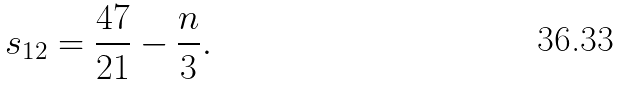Convert formula to latex. <formula><loc_0><loc_0><loc_500><loc_500>s _ { 1 2 } = \frac { 4 7 } { 2 1 } - \frac { n } { 3 } .</formula> 